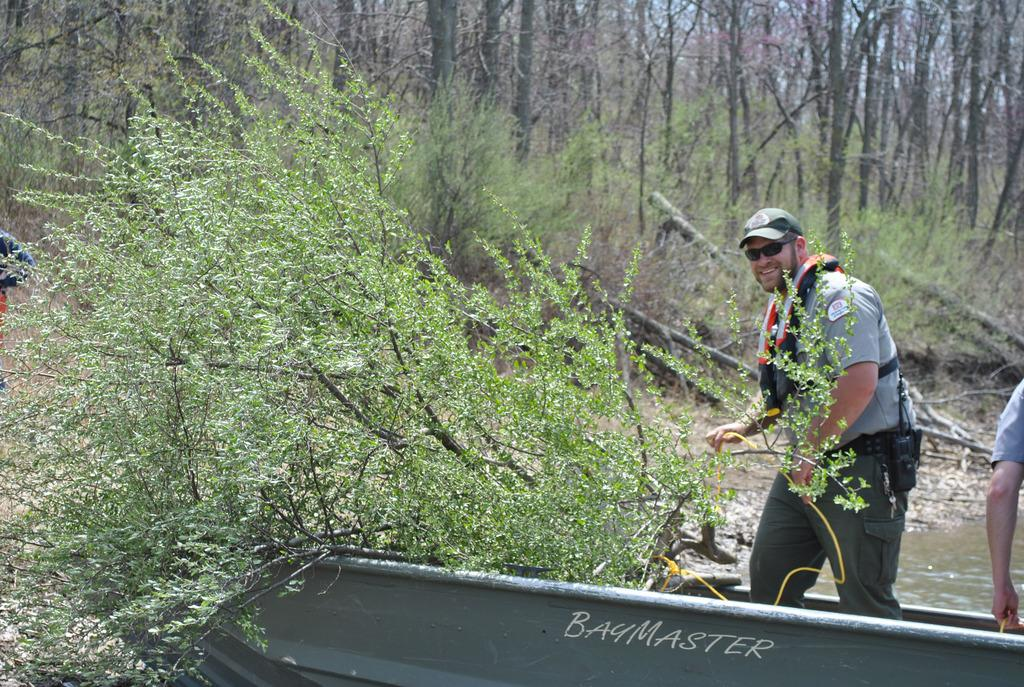<image>
Offer a succinct explanation of the picture presented. Two fisherman are riding a boat called BayMaster. 